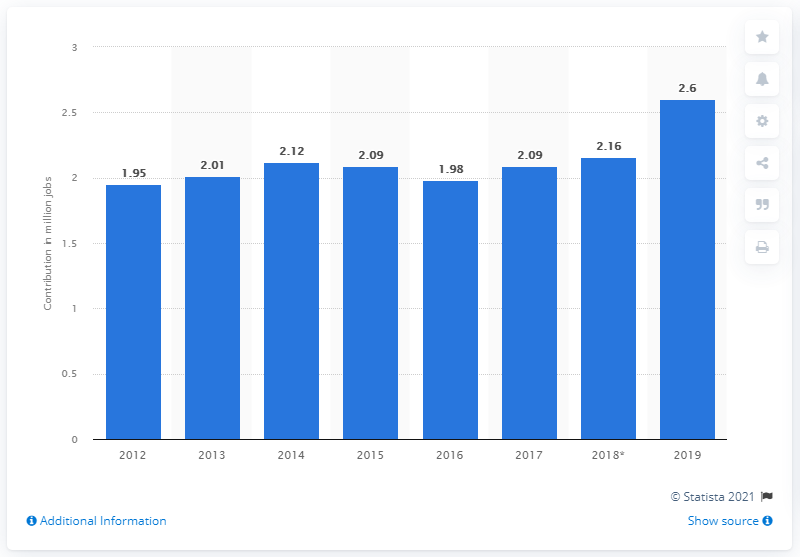Highlight a few significant elements in this photo. In 2019, the travel and tourism industry in Turkey created approximately 2.6 million jobs. In 2012, travel and tourism contributed to employment in Turkey. 